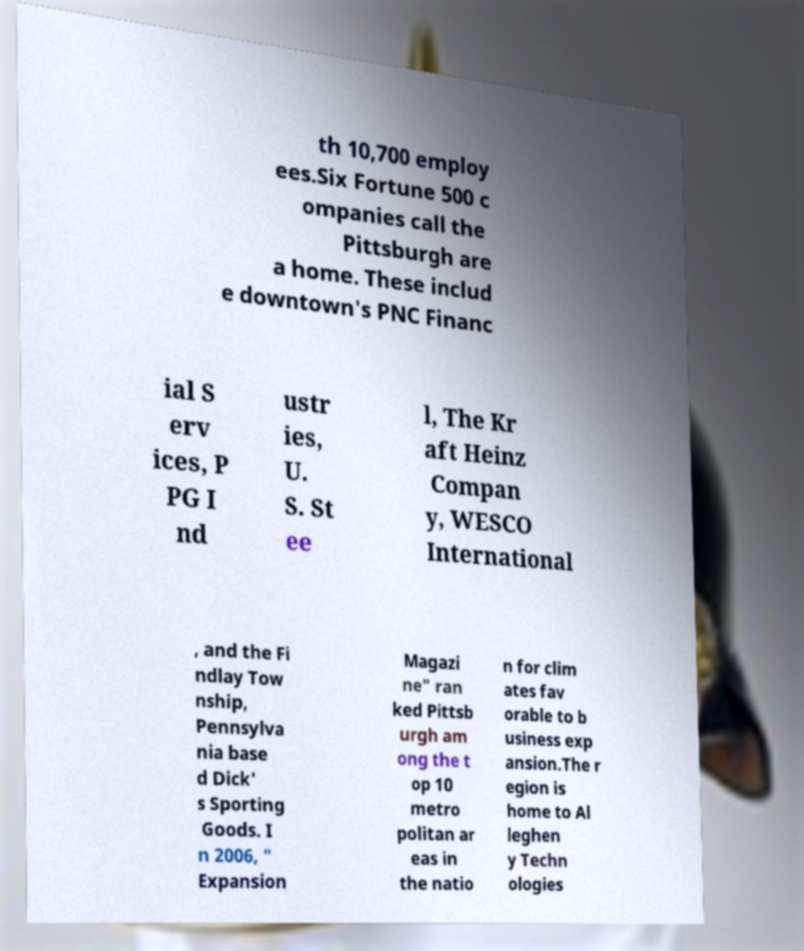There's text embedded in this image that I need extracted. Can you transcribe it verbatim? th 10,700 employ ees.Six Fortune 500 c ompanies call the Pittsburgh are a home. These includ e downtown's PNC Financ ial S erv ices, P PG I nd ustr ies, U. S. St ee l, The Kr aft Heinz Compan y, WESCO International , and the Fi ndlay Tow nship, Pennsylva nia base d Dick' s Sporting Goods. I n 2006, " Expansion Magazi ne" ran ked Pittsb urgh am ong the t op 10 metro politan ar eas in the natio n for clim ates fav orable to b usiness exp ansion.The r egion is home to Al leghen y Techn ologies 